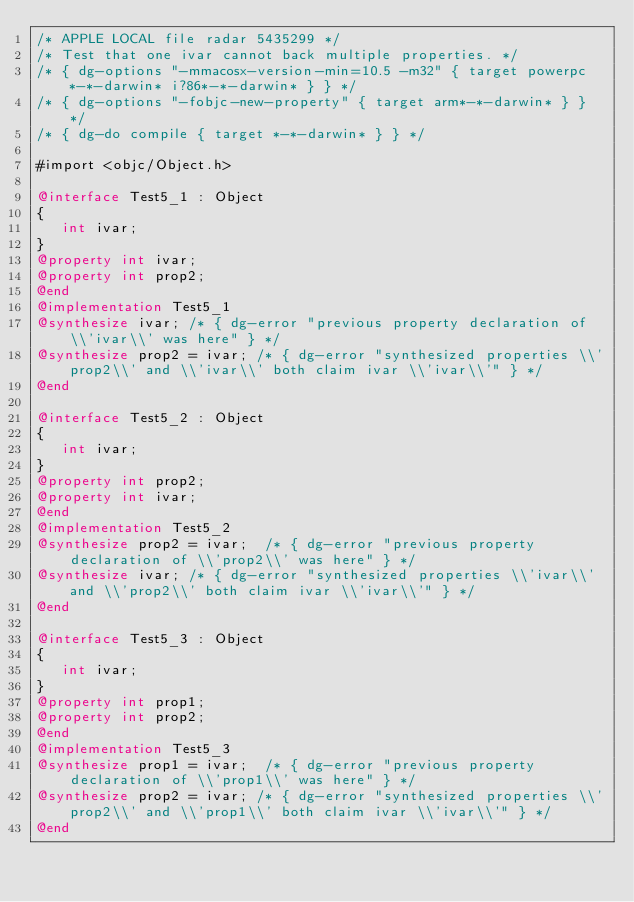Convert code to text. <code><loc_0><loc_0><loc_500><loc_500><_ObjectiveC_>/* APPLE LOCAL file radar 5435299 */
/* Test that one ivar cannot back multiple properties. */
/* { dg-options "-mmacosx-version-min=10.5 -m32" { target powerpc*-*-darwin* i?86*-*-darwin* } } */
/* { dg-options "-fobjc-new-property" { target arm*-*-darwin* } } */
/* { dg-do compile { target *-*-darwin* } } */

#import <objc/Object.h>

@interface Test5_1 : Object
{
   int ivar;
}
@property int ivar;
@property int prop2;
@end
@implementation Test5_1
@synthesize ivar; /* { dg-error "previous property declaration of \\'ivar\\' was here" } */
@synthesize prop2 = ivar; /* { dg-error "synthesized properties \\'prop2\\' and \\'ivar\\' both claim ivar \\'ivar\\'" } */
@end

@interface Test5_2 : Object
{
   int ivar;
}
@property int prop2;
@property int ivar;
@end
@implementation Test5_2
@synthesize prop2 = ivar;  /* { dg-error "previous property declaration of \\'prop2\\' was here" } */
@synthesize ivar; /* { dg-error "synthesized properties \\'ivar\\' and \\'prop2\\' both claim ivar \\'ivar\\'" } */
@end

@interface Test5_3 : Object
{
   int ivar;
}
@property int prop1;
@property int prop2;
@end
@implementation Test5_3
@synthesize prop1 = ivar;  /* { dg-error "previous property declaration of \\'prop1\\' was here" } */
@synthesize prop2 = ivar; /* { dg-error "synthesized properties \\'prop2\\' and \\'prop1\\' both claim ivar \\'ivar\\'" } */
@end
</code> 